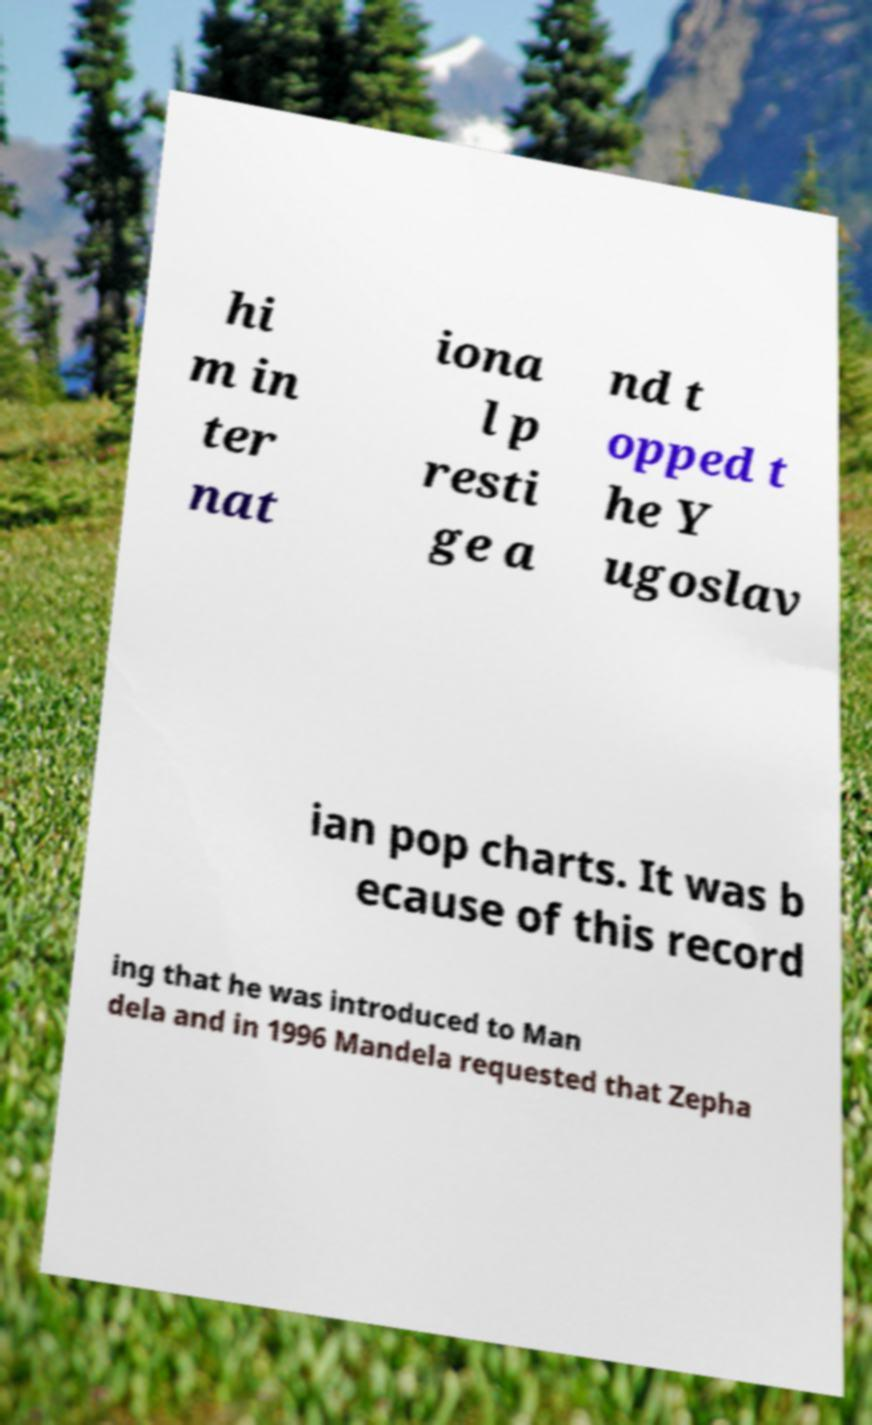What messages or text are displayed in this image? I need them in a readable, typed format. hi m in ter nat iona l p resti ge a nd t opped t he Y ugoslav ian pop charts. It was b ecause of this record ing that he was introduced to Man dela and in 1996 Mandela requested that Zepha 